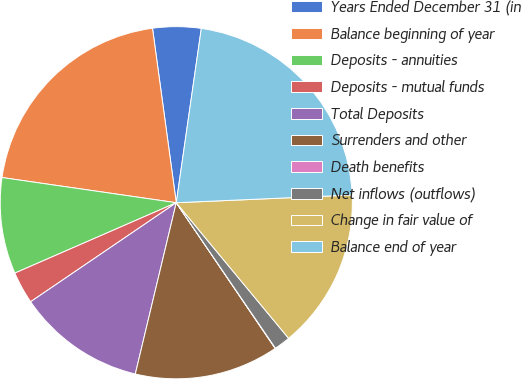Convert chart. <chart><loc_0><loc_0><loc_500><loc_500><pie_chart><fcel>Years Ended December 31 (in<fcel>Balance beginning of year<fcel>Deposits - annuities<fcel>Deposits - mutual funds<fcel>Total Deposits<fcel>Surrenders and other<fcel>Death benefits<fcel>Net inflows (outflows)<fcel>Change in fair value of<fcel>Balance end of year<nl><fcel>4.43%<fcel>20.56%<fcel>8.83%<fcel>2.96%<fcel>11.76%<fcel>13.23%<fcel>0.03%<fcel>1.49%<fcel>14.69%<fcel>22.03%<nl></chart> 